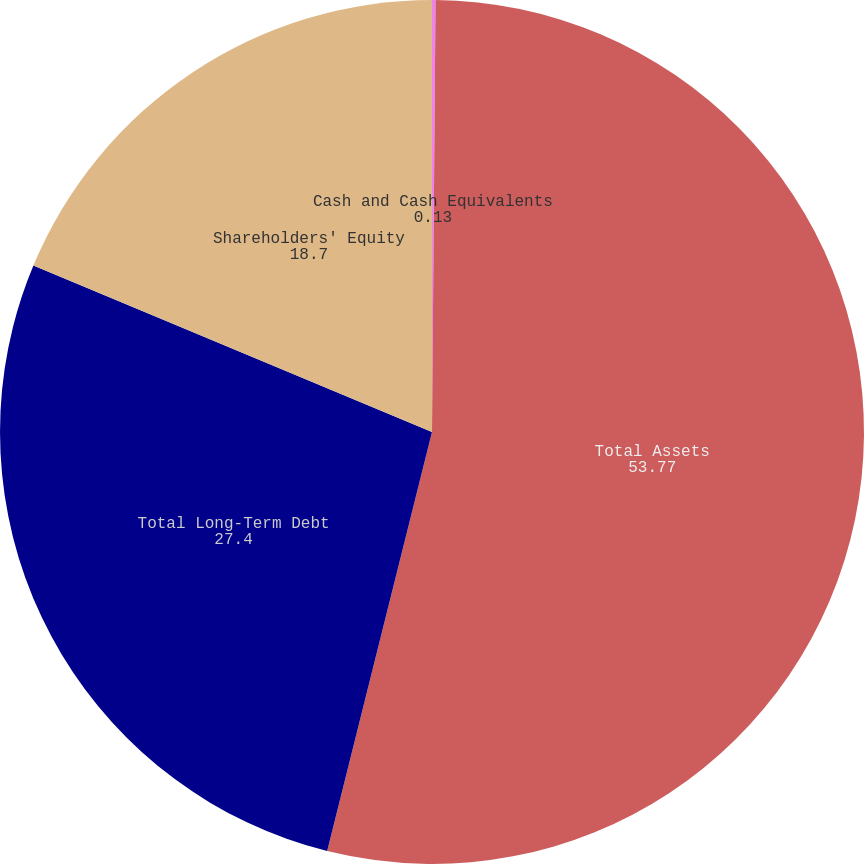<chart> <loc_0><loc_0><loc_500><loc_500><pie_chart><fcel>Cash and Cash Equivalents<fcel>Total Assets<fcel>Total Long-Term Debt<fcel>Shareholders' Equity<nl><fcel>0.13%<fcel>53.77%<fcel>27.4%<fcel>18.7%<nl></chart> 